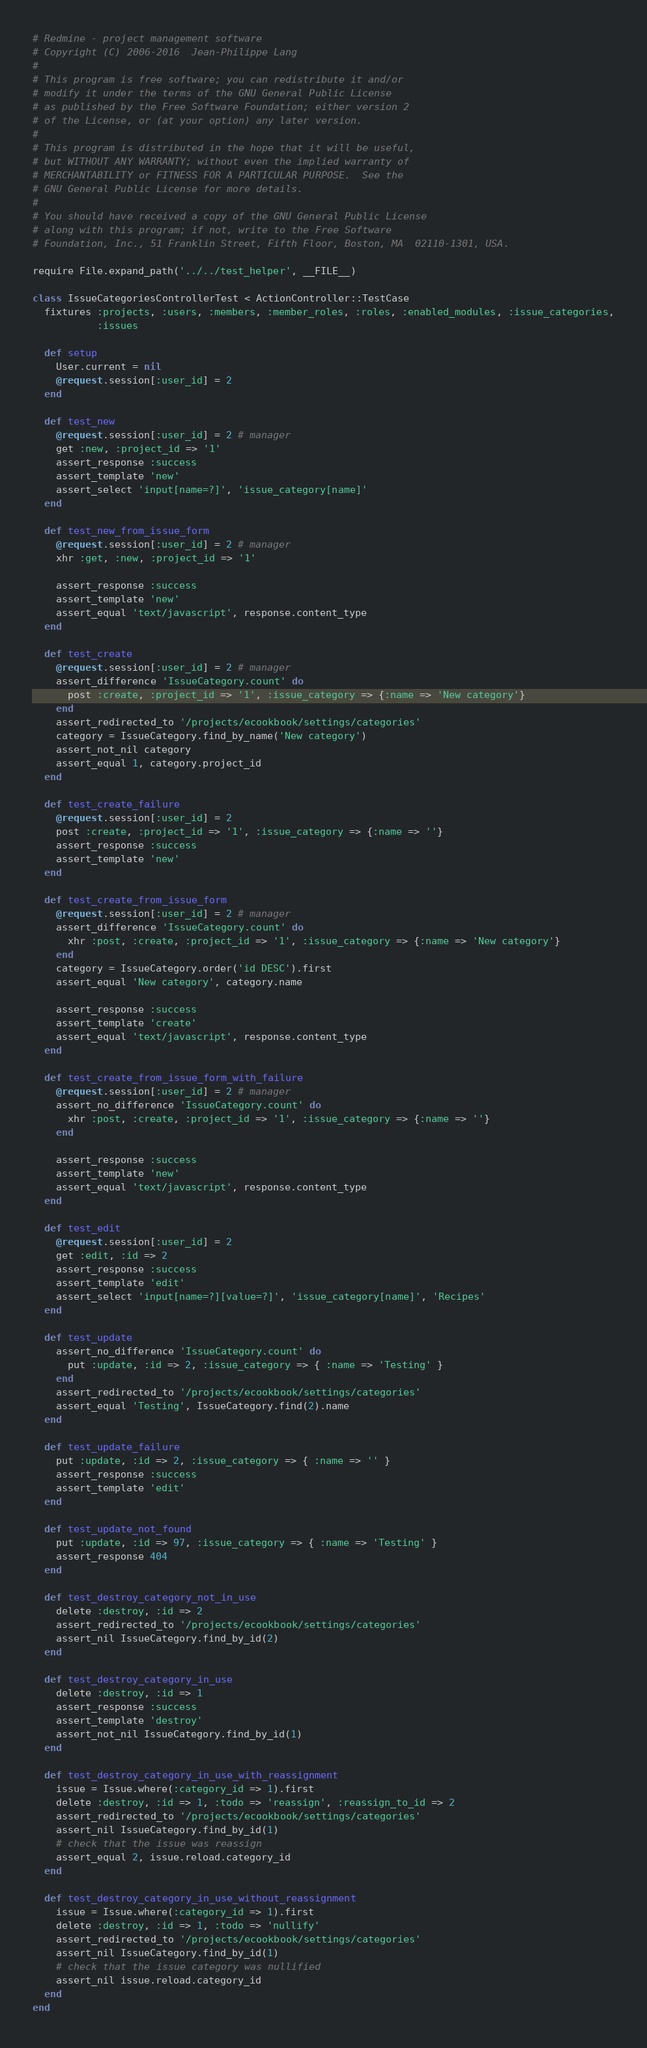Convert code to text. <code><loc_0><loc_0><loc_500><loc_500><_Ruby_># Redmine - project management software
# Copyright (C) 2006-2016  Jean-Philippe Lang
#
# This program is free software; you can redistribute it and/or
# modify it under the terms of the GNU General Public License
# as published by the Free Software Foundation; either version 2
# of the License, or (at your option) any later version.
#
# This program is distributed in the hope that it will be useful,
# but WITHOUT ANY WARRANTY; without even the implied warranty of
# MERCHANTABILITY or FITNESS FOR A PARTICULAR PURPOSE.  See the
# GNU General Public License for more details.
#
# You should have received a copy of the GNU General Public License
# along with this program; if not, write to the Free Software
# Foundation, Inc., 51 Franklin Street, Fifth Floor, Boston, MA  02110-1301, USA.

require File.expand_path('../../test_helper', __FILE__)

class IssueCategoriesControllerTest < ActionController::TestCase
  fixtures :projects, :users, :members, :member_roles, :roles, :enabled_modules, :issue_categories,
           :issues

  def setup
    User.current = nil
    @request.session[:user_id] = 2
  end

  def test_new
    @request.session[:user_id] = 2 # manager
    get :new, :project_id => '1'
    assert_response :success
    assert_template 'new'
    assert_select 'input[name=?]', 'issue_category[name]'
  end

  def test_new_from_issue_form
    @request.session[:user_id] = 2 # manager
    xhr :get, :new, :project_id => '1'

    assert_response :success
    assert_template 'new'
    assert_equal 'text/javascript', response.content_type
  end

  def test_create
    @request.session[:user_id] = 2 # manager
    assert_difference 'IssueCategory.count' do
      post :create, :project_id => '1', :issue_category => {:name => 'New category'}
    end
    assert_redirected_to '/projects/ecookbook/settings/categories'
    category = IssueCategory.find_by_name('New category')
    assert_not_nil category
    assert_equal 1, category.project_id
  end

  def test_create_failure
    @request.session[:user_id] = 2
    post :create, :project_id => '1', :issue_category => {:name => ''}
    assert_response :success
    assert_template 'new'
  end

  def test_create_from_issue_form
    @request.session[:user_id] = 2 # manager
    assert_difference 'IssueCategory.count' do
      xhr :post, :create, :project_id => '1', :issue_category => {:name => 'New category'}
    end
    category = IssueCategory.order('id DESC').first
    assert_equal 'New category', category.name

    assert_response :success
    assert_template 'create'
    assert_equal 'text/javascript', response.content_type
  end

  def test_create_from_issue_form_with_failure
    @request.session[:user_id] = 2 # manager
    assert_no_difference 'IssueCategory.count' do
      xhr :post, :create, :project_id => '1', :issue_category => {:name => ''}
    end

    assert_response :success
    assert_template 'new'
    assert_equal 'text/javascript', response.content_type
  end

  def test_edit
    @request.session[:user_id] = 2
    get :edit, :id => 2
    assert_response :success
    assert_template 'edit'
    assert_select 'input[name=?][value=?]', 'issue_category[name]', 'Recipes'
  end

  def test_update
    assert_no_difference 'IssueCategory.count' do
      put :update, :id => 2, :issue_category => { :name => 'Testing' }
    end
    assert_redirected_to '/projects/ecookbook/settings/categories'
    assert_equal 'Testing', IssueCategory.find(2).name
  end

  def test_update_failure
    put :update, :id => 2, :issue_category => { :name => '' }
    assert_response :success
    assert_template 'edit'
  end

  def test_update_not_found
    put :update, :id => 97, :issue_category => { :name => 'Testing' }
    assert_response 404
  end

  def test_destroy_category_not_in_use
    delete :destroy, :id => 2
    assert_redirected_to '/projects/ecookbook/settings/categories'
    assert_nil IssueCategory.find_by_id(2)
  end

  def test_destroy_category_in_use
    delete :destroy, :id => 1
    assert_response :success
    assert_template 'destroy'
    assert_not_nil IssueCategory.find_by_id(1)
  end

  def test_destroy_category_in_use_with_reassignment
    issue = Issue.where(:category_id => 1).first
    delete :destroy, :id => 1, :todo => 'reassign', :reassign_to_id => 2
    assert_redirected_to '/projects/ecookbook/settings/categories'
    assert_nil IssueCategory.find_by_id(1)
    # check that the issue was reassign
    assert_equal 2, issue.reload.category_id
  end

  def test_destroy_category_in_use_without_reassignment
    issue = Issue.where(:category_id => 1).first
    delete :destroy, :id => 1, :todo => 'nullify'
    assert_redirected_to '/projects/ecookbook/settings/categories'
    assert_nil IssueCategory.find_by_id(1)
    # check that the issue category was nullified
    assert_nil issue.reload.category_id
  end
end
</code> 